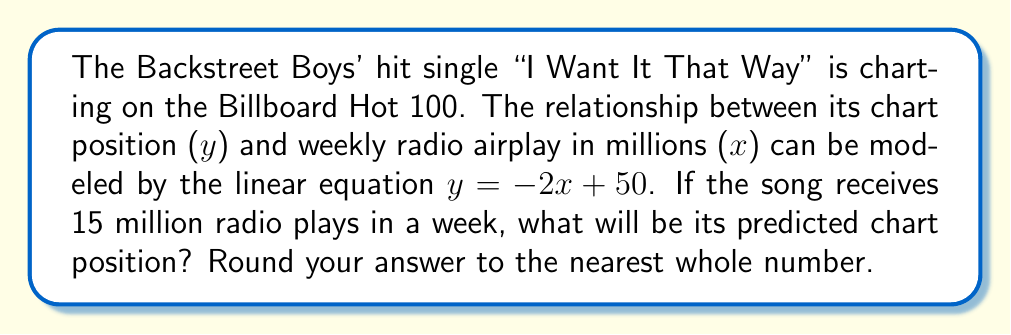Can you answer this question? Let's approach this step-by-step:

1) We are given the linear equation: $y = -2x + 50$
   Where y is the chart position and x is the weekly radio airplay in millions.

2) We need to find y when x = 15 (15 million radio plays).

3) Let's substitute x = 15 into the equation:
   $y = -2(15) + 50$

4) Now, let's solve this:
   $y = -30 + 50$
   $y = 20$

5) The question asks to round to the nearest whole number, but 20 is already a whole number, so no rounding is necessary.

Therefore, with 15 million radio plays, the predicted chart position for "I Want It That Way" would be 20.
Answer: 20 